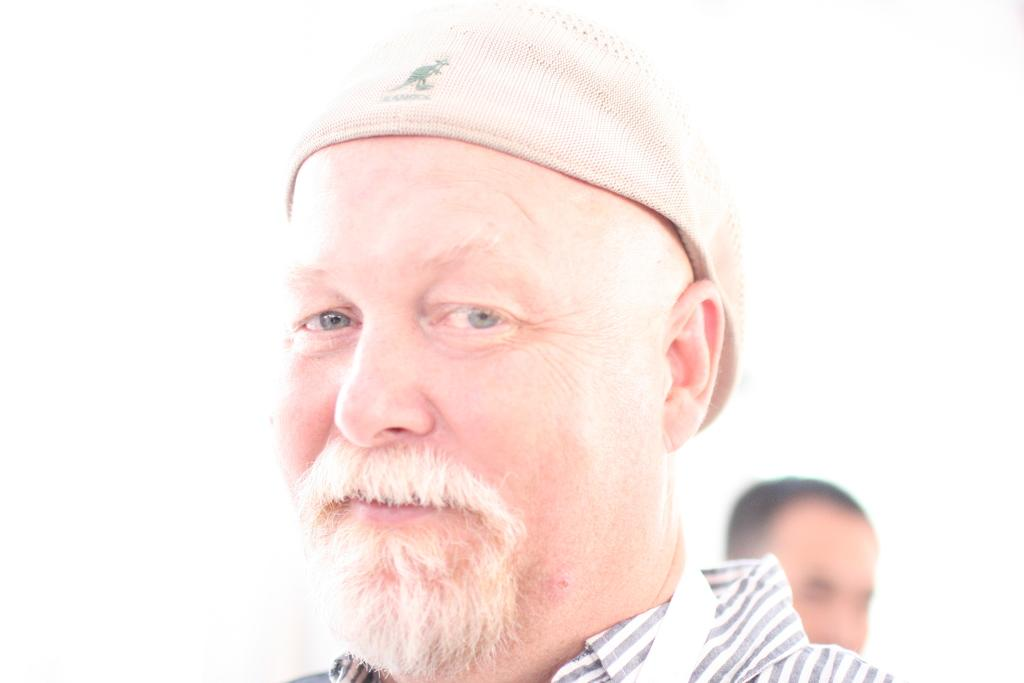What is the main subject in the middle of the image? There is a person in the middle of the image. What is the person wearing on their head? The person is wearing a cap. What is the person wearing on their upper body? The person is wearing a shirt. What is the person's facial expression in the image? The person is smiling. Can you describe the background of the image? The background is white in color. How many people are visible in the image? There is one person in the middle and another person in the background, making a total of two people. What is the person's wish for the future in the image? There is no information about the person's wishes in the image. Does the existence of science play a role in the image? The image does not depict any scientific concepts or activities, so the existence of science is not relevant to the image. 